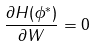Convert formula to latex. <formula><loc_0><loc_0><loc_500><loc_500>\frac { \partial H ( \phi ^ { * } ) } { \partial W } = 0</formula> 